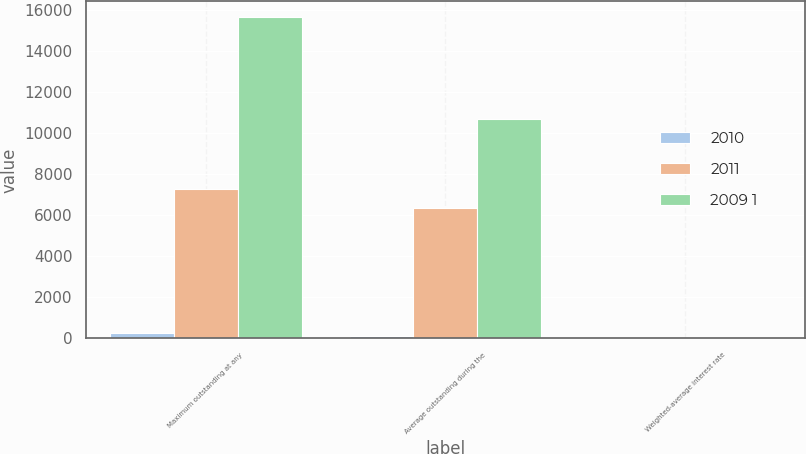Convert chart to OTSL. <chart><loc_0><loc_0><loc_500><loc_500><stacked_bar_chart><ecel><fcel>Maximum outstanding at any<fcel>Average outstanding during the<fcel>Weighted-average interest rate<nl><fcel>2010<fcel>271<fcel>113<fcel>0.47<nl><fcel>2011<fcel>7275<fcel>6339<fcel>0.32<nl><fcel>2009 1<fcel>15645<fcel>10691<fcel>1.26<nl></chart> 